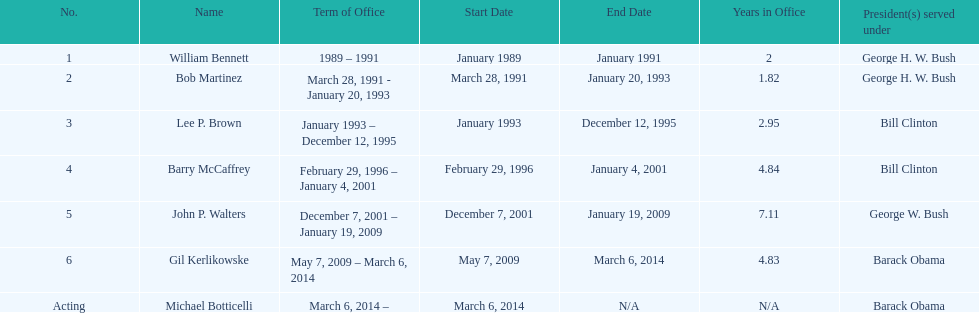What were the number of directors that stayed in office more than three years? 3. 